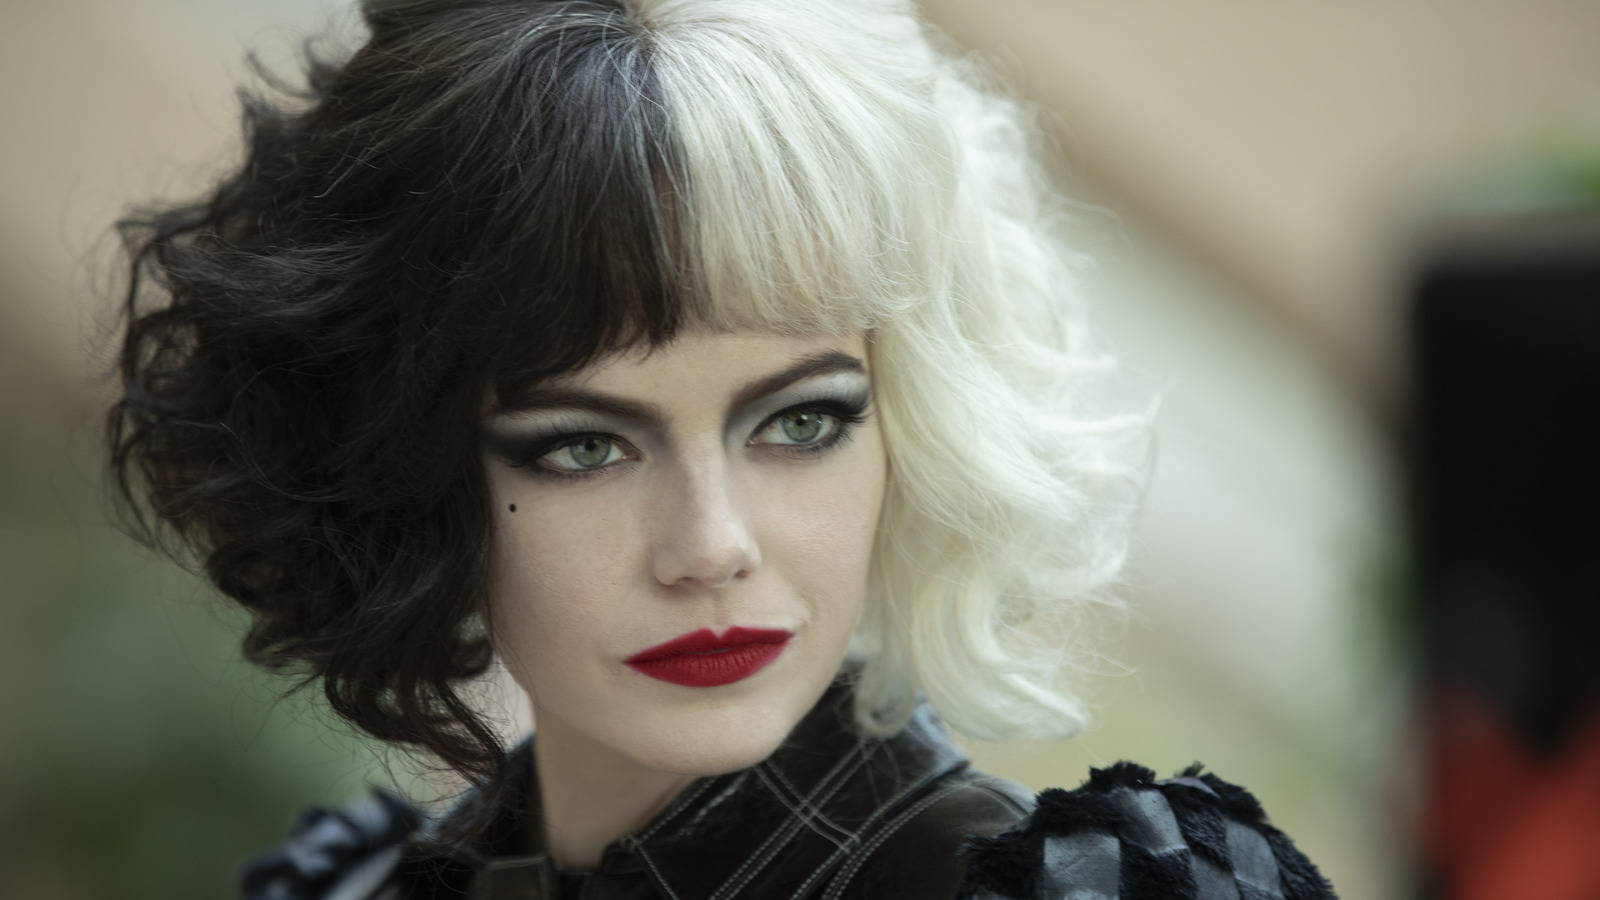Could you describe the emotional tone conveyed by her facial expression and posture? Her facial expression and posture convey a demeanor filled with confidence and a touch of defiance. The slight tilt of her chin and the direct, almost challenging gaze suggest a character that is unafraid and confrontational. This bolsters the image of Cruella as a commanding figure, reflecting her determination and perhaps hinting at her readiness to pursue her ambitions relentlessly, regardless of the moral implications. 